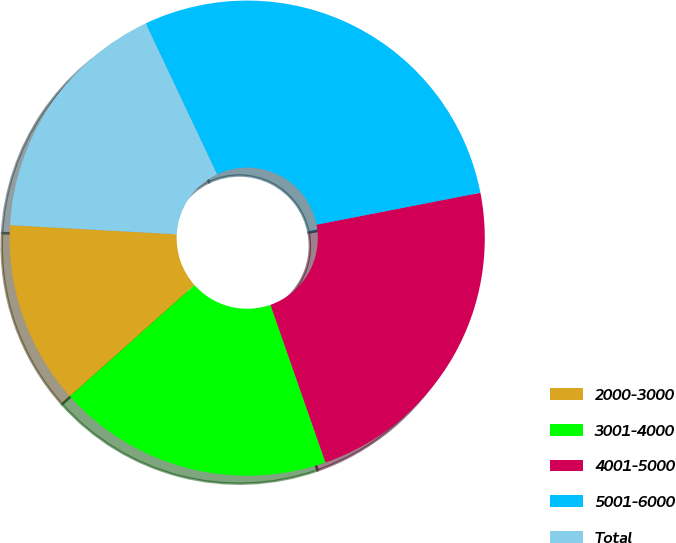Convert chart. <chart><loc_0><loc_0><loc_500><loc_500><pie_chart><fcel>2000-3000<fcel>3001-4000<fcel>4001-5000<fcel>5001-6000<fcel>Total<nl><fcel>12.47%<fcel>18.75%<fcel>22.72%<fcel>28.96%<fcel>17.1%<nl></chart> 